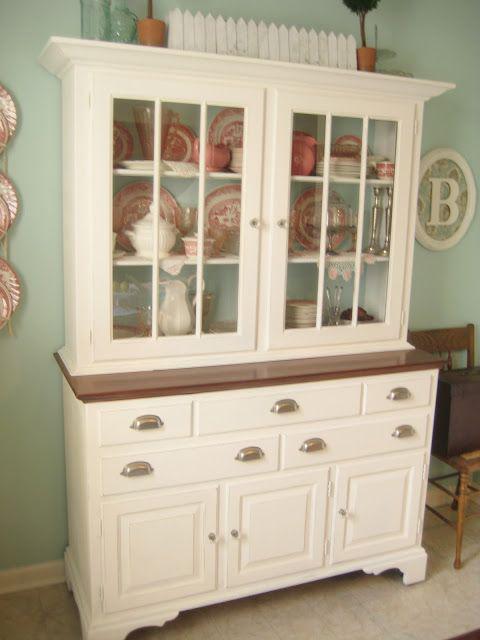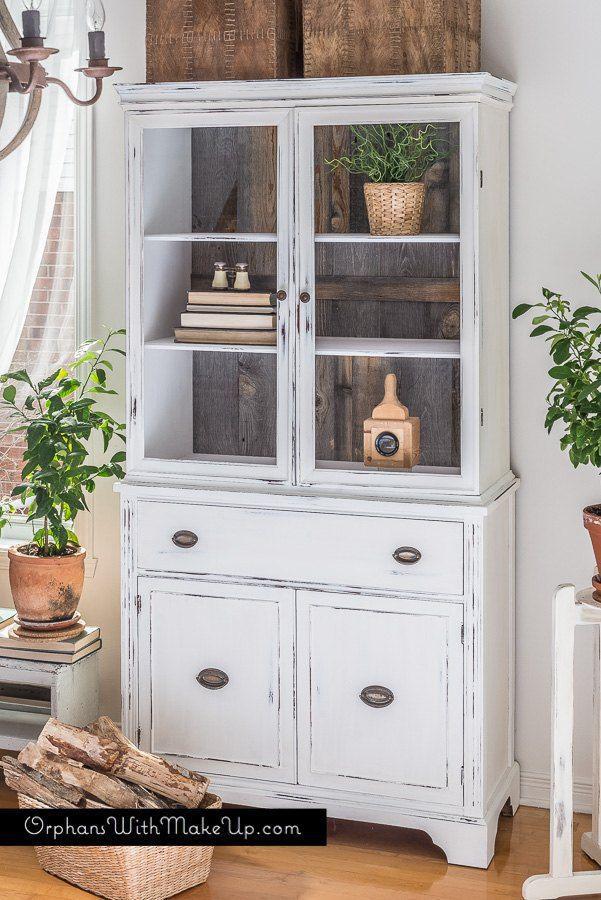The first image is the image on the left, the second image is the image on the right. Evaluate the accuracy of this statement regarding the images: "The top of one cabinet is not flat, and features two curl shapes that face each other.". Is it true? Answer yes or no. No. The first image is the image on the left, the second image is the image on the right. Given the left and right images, does the statement "The white cabinet on the left has an ornate, curved top piece" hold true? Answer yes or no. No. 